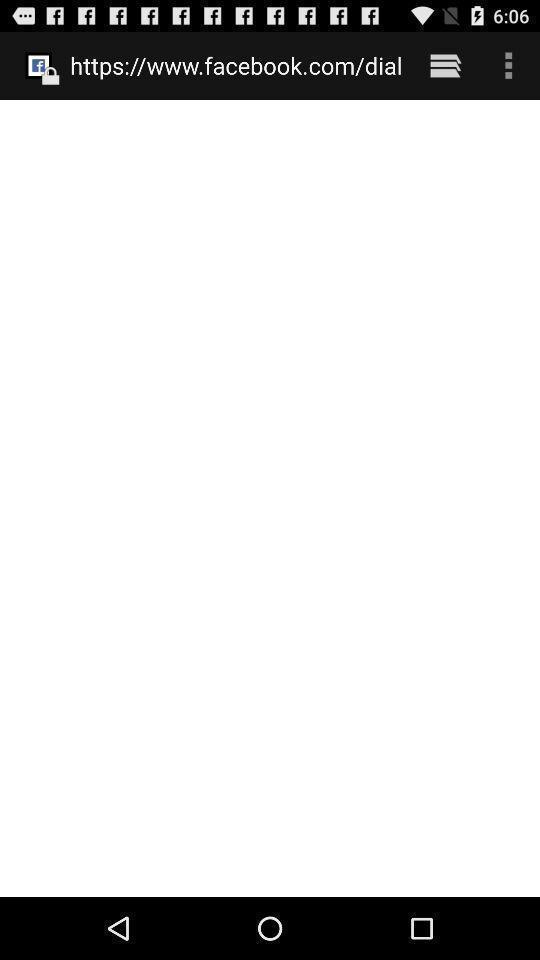Provide a detailed account of this screenshot. Page displaying a web-page link with other options. 